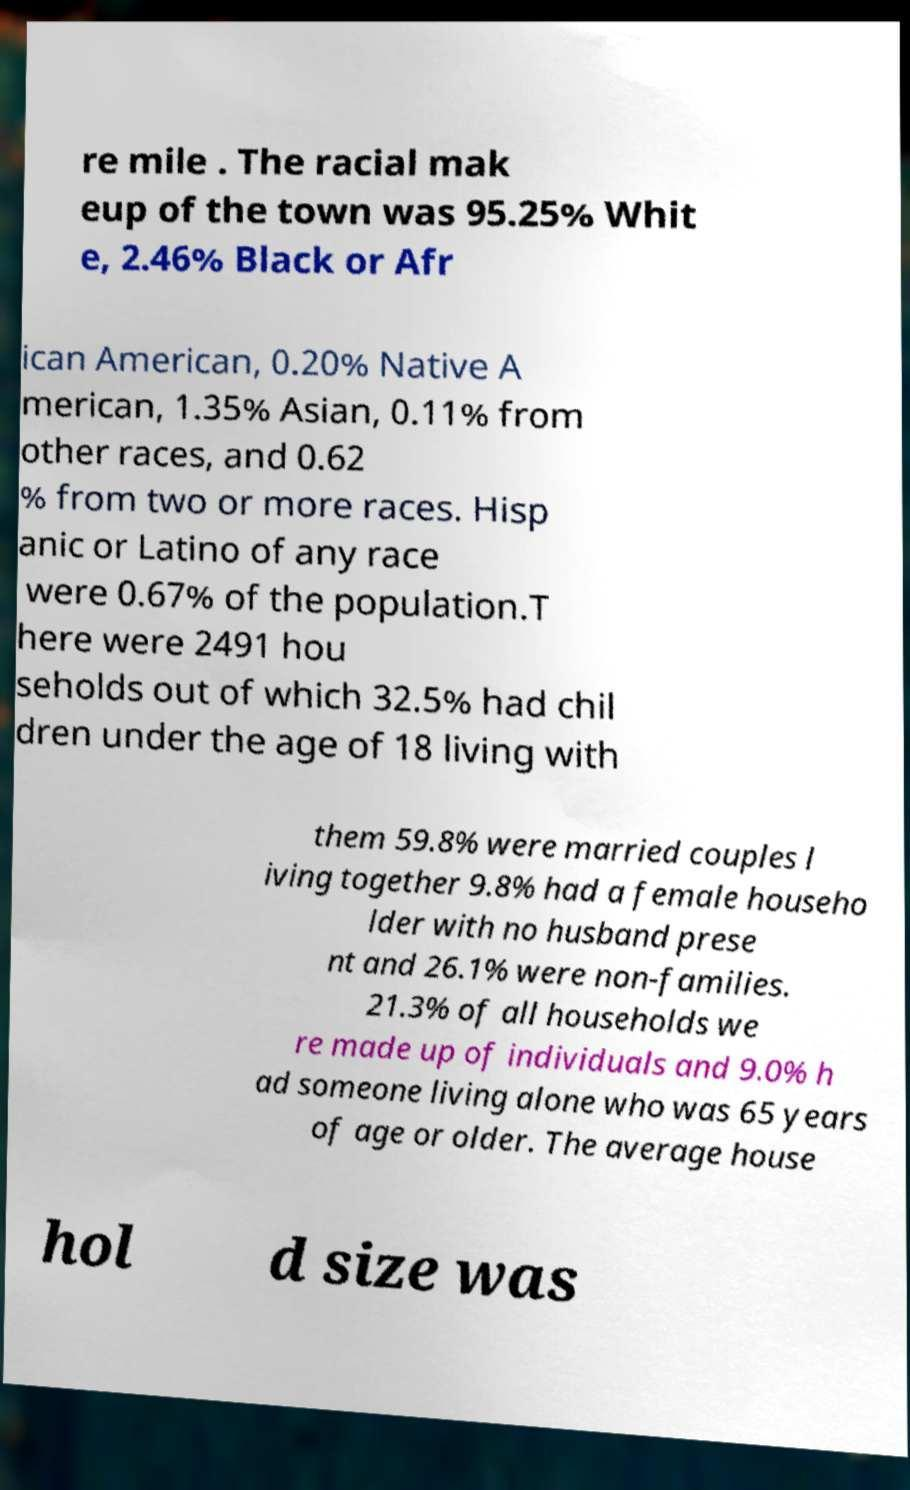Please identify and transcribe the text found in this image. re mile . The racial mak eup of the town was 95.25% Whit e, 2.46% Black or Afr ican American, 0.20% Native A merican, 1.35% Asian, 0.11% from other races, and 0.62 % from two or more races. Hisp anic or Latino of any race were 0.67% of the population.T here were 2491 hou seholds out of which 32.5% had chil dren under the age of 18 living with them 59.8% were married couples l iving together 9.8% had a female househo lder with no husband prese nt and 26.1% were non-families. 21.3% of all households we re made up of individuals and 9.0% h ad someone living alone who was 65 years of age or older. The average house hol d size was 